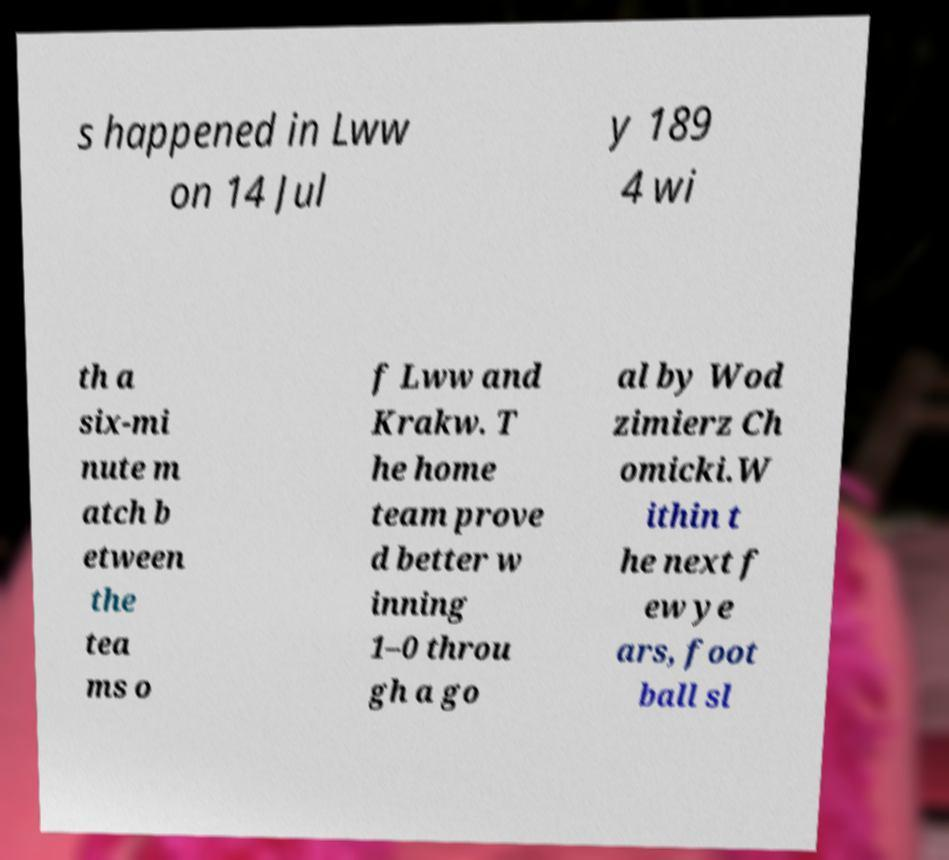Please identify and transcribe the text found in this image. s happened in Lww on 14 Jul y 189 4 wi th a six-mi nute m atch b etween the tea ms o f Lww and Krakw. T he home team prove d better w inning 1–0 throu gh a go al by Wod zimierz Ch omicki.W ithin t he next f ew ye ars, foot ball sl 